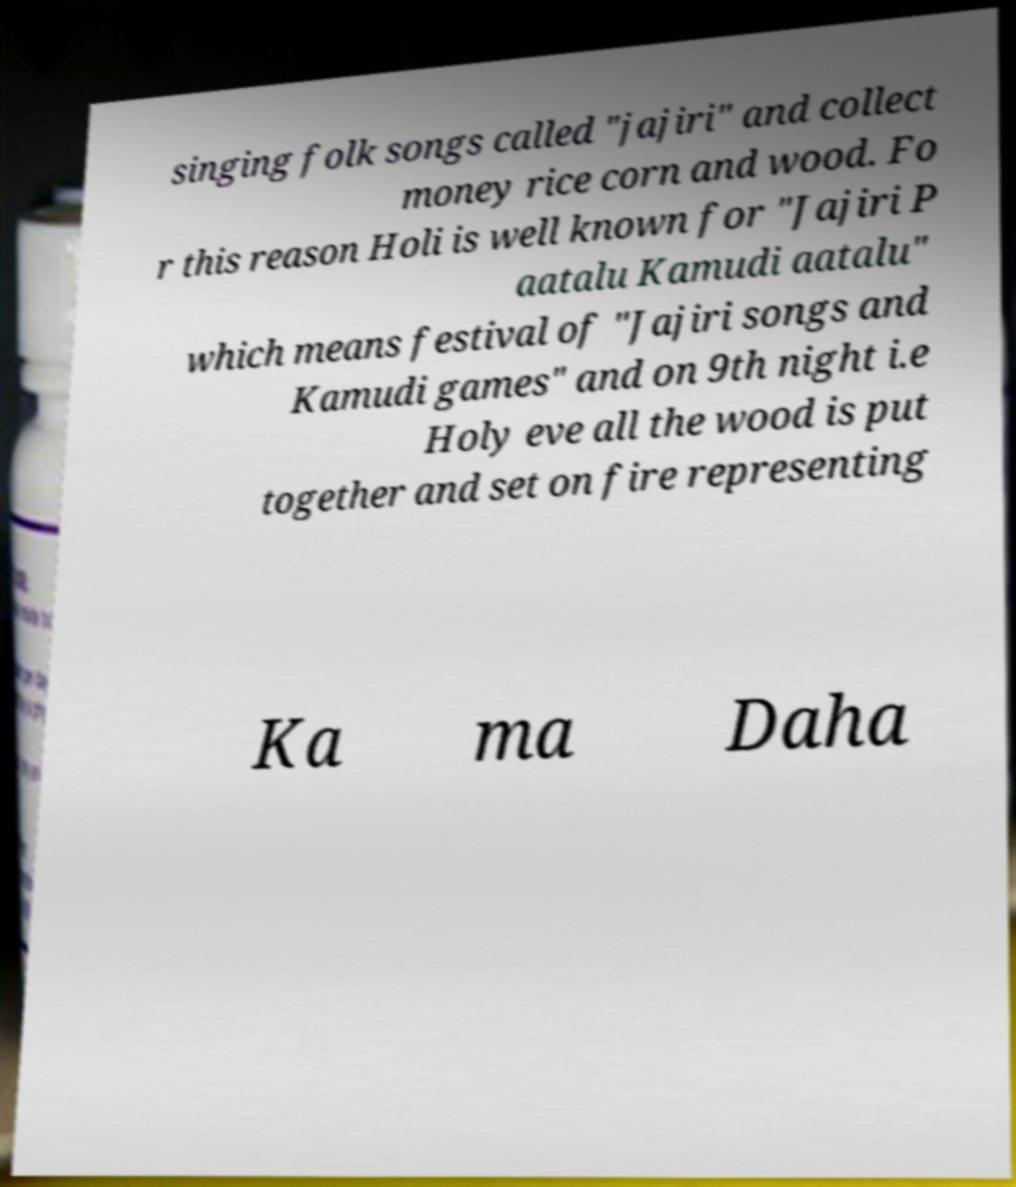There's text embedded in this image that I need extracted. Can you transcribe it verbatim? singing folk songs called "jajiri" and collect money rice corn and wood. Fo r this reason Holi is well known for "Jajiri P aatalu Kamudi aatalu" which means festival of "Jajiri songs and Kamudi games" and on 9th night i.e Holy eve all the wood is put together and set on fire representing Ka ma Daha 